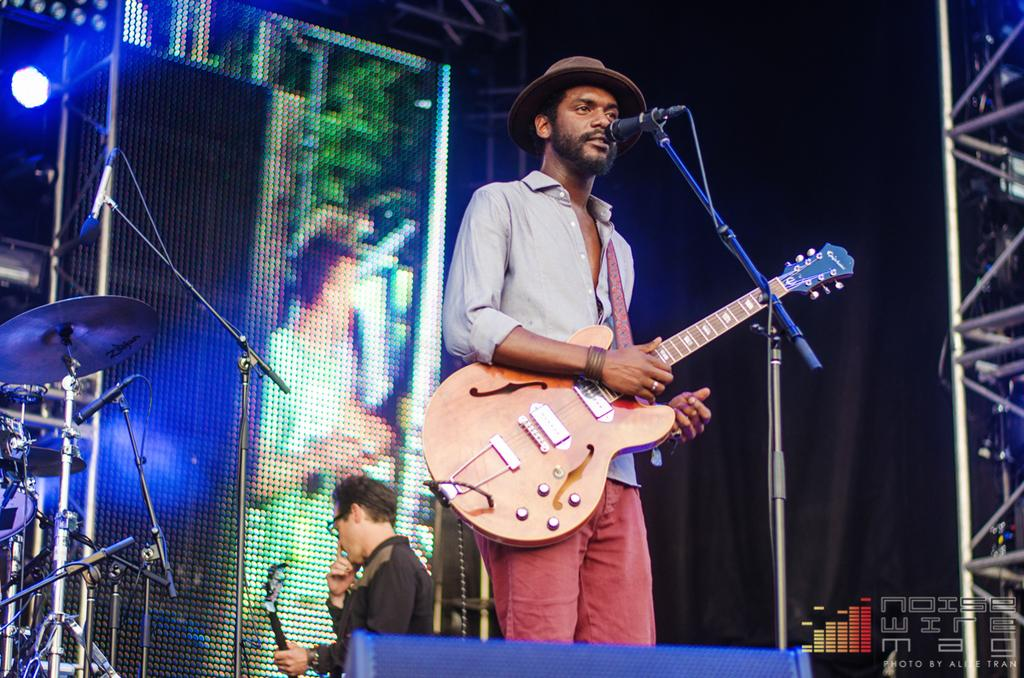How many people are in the image? There are two persons in the image. What is one person doing in the image? One person is standing and holding a guitar. What equipment is present for amplifying sound in the image? There is a microphone with a stand in the image. What can be seen in the background of the image? Musical instruments and focusing lights are visible in the background. What type of sorting task is the fireman performing in the image? There is no fireman present in the image, and therefore no sorting task can be observed. 